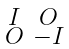<formula> <loc_0><loc_0><loc_500><loc_500>\begin{smallmatrix} I & O \\ O & - I \end{smallmatrix}</formula> 